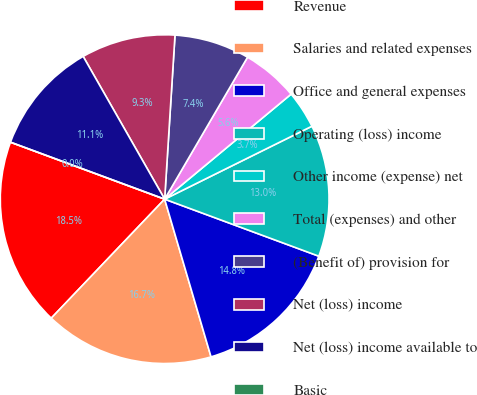Convert chart to OTSL. <chart><loc_0><loc_0><loc_500><loc_500><pie_chart><fcel>Revenue<fcel>Salaries and related expenses<fcel>Office and general expenses<fcel>Operating (loss) income<fcel>Other income (expense) net<fcel>Total (expenses) and other<fcel>(Benefit of) provision for<fcel>Net (loss) income<fcel>Net (loss) income available to<fcel>Basic<nl><fcel>18.52%<fcel>16.67%<fcel>14.81%<fcel>12.96%<fcel>3.71%<fcel>5.56%<fcel>7.41%<fcel>9.26%<fcel>11.11%<fcel>0.0%<nl></chart> 